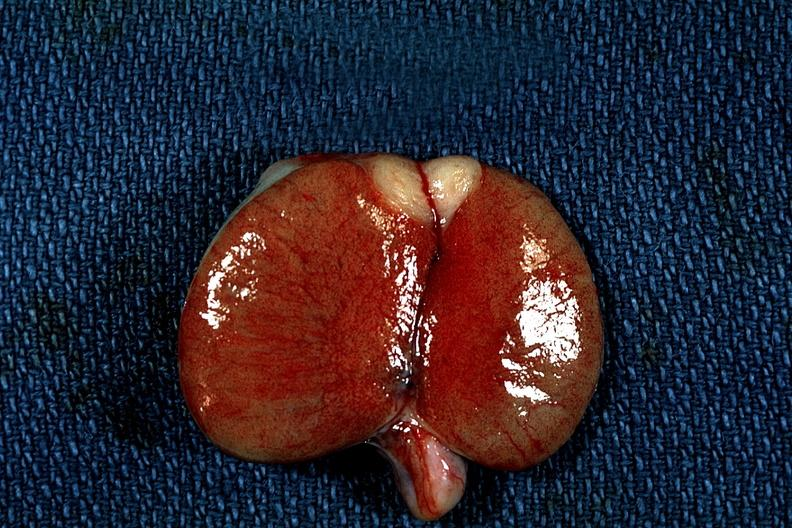what does this image show?
Answer the question using a single word or phrase. Discrete tumor mass 